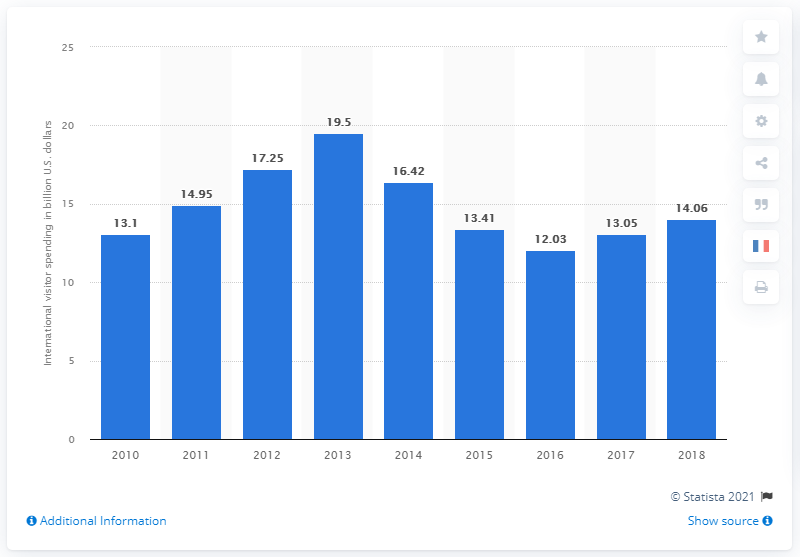Outline some significant characteristics in this image. In 2018, the total international visitor spending in Paris was 14.06 billion U.S. dollars. In the previous year, international visitor spending in Paris was 13.05 billion U.S. dollars. 